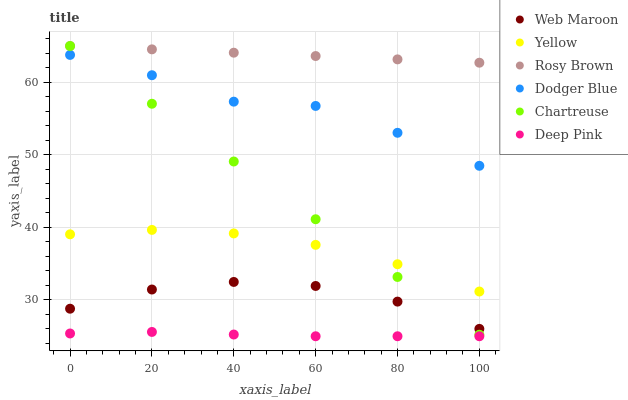Does Deep Pink have the minimum area under the curve?
Answer yes or no. Yes. Does Rosy Brown have the maximum area under the curve?
Answer yes or no. Yes. Does Web Maroon have the minimum area under the curve?
Answer yes or no. No. Does Web Maroon have the maximum area under the curve?
Answer yes or no. No. Is Chartreuse the smoothest?
Answer yes or no. Yes. Is Dodger Blue the roughest?
Answer yes or no. Yes. Is Rosy Brown the smoothest?
Answer yes or no. No. Is Rosy Brown the roughest?
Answer yes or no. No. Does Deep Pink have the lowest value?
Answer yes or no. Yes. Does Web Maroon have the lowest value?
Answer yes or no. No. Does Chartreuse have the highest value?
Answer yes or no. Yes. Does Web Maroon have the highest value?
Answer yes or no. No. Is Deep Pink less than Chartreuse?
Answer yes or no. Yes. Is Yellow greater than Deep Pink?
Answer yes or no. Yes. Does Chartreuse intersect Web Maroon?
Answer yes or no. Yes. Is Chartreuse less than Web Maroon?
Answer yes or no. No. Is Chartreuse greater than Web Maroon?
Answer yes or no. No. Does Deep Pink intersect Chartreuse?
Answer yes or no. No. 